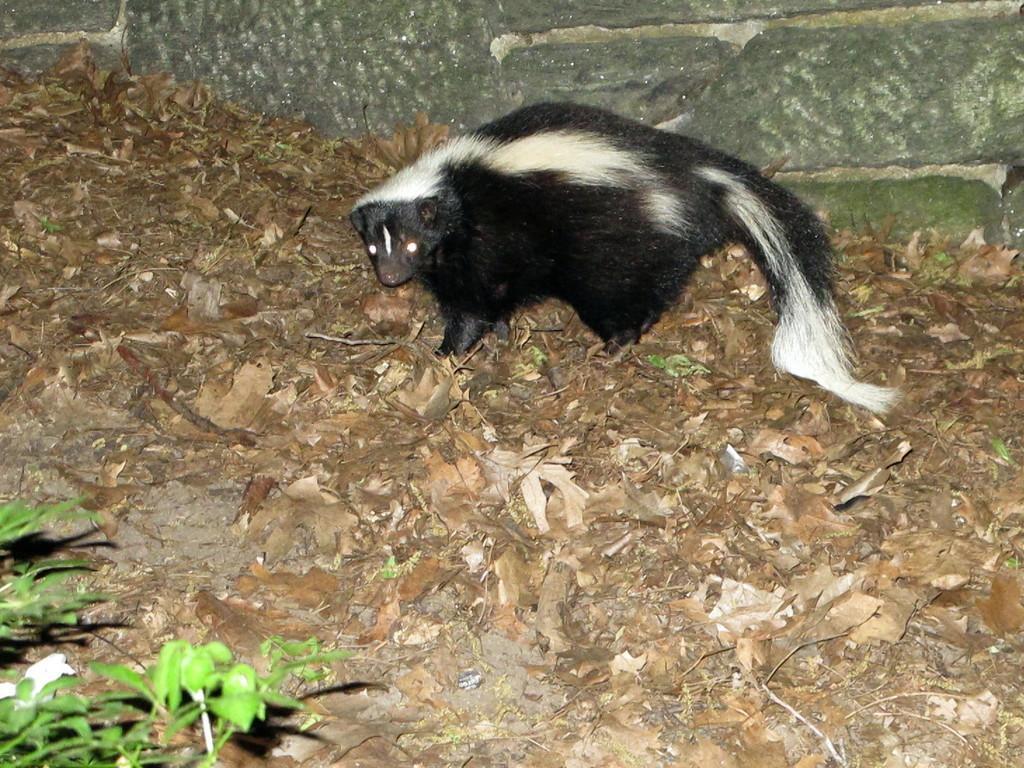Can you describe this image briefly? There is a black and white color animal standing on the ground, on which, there are dry leaves and plants and near a wall. 